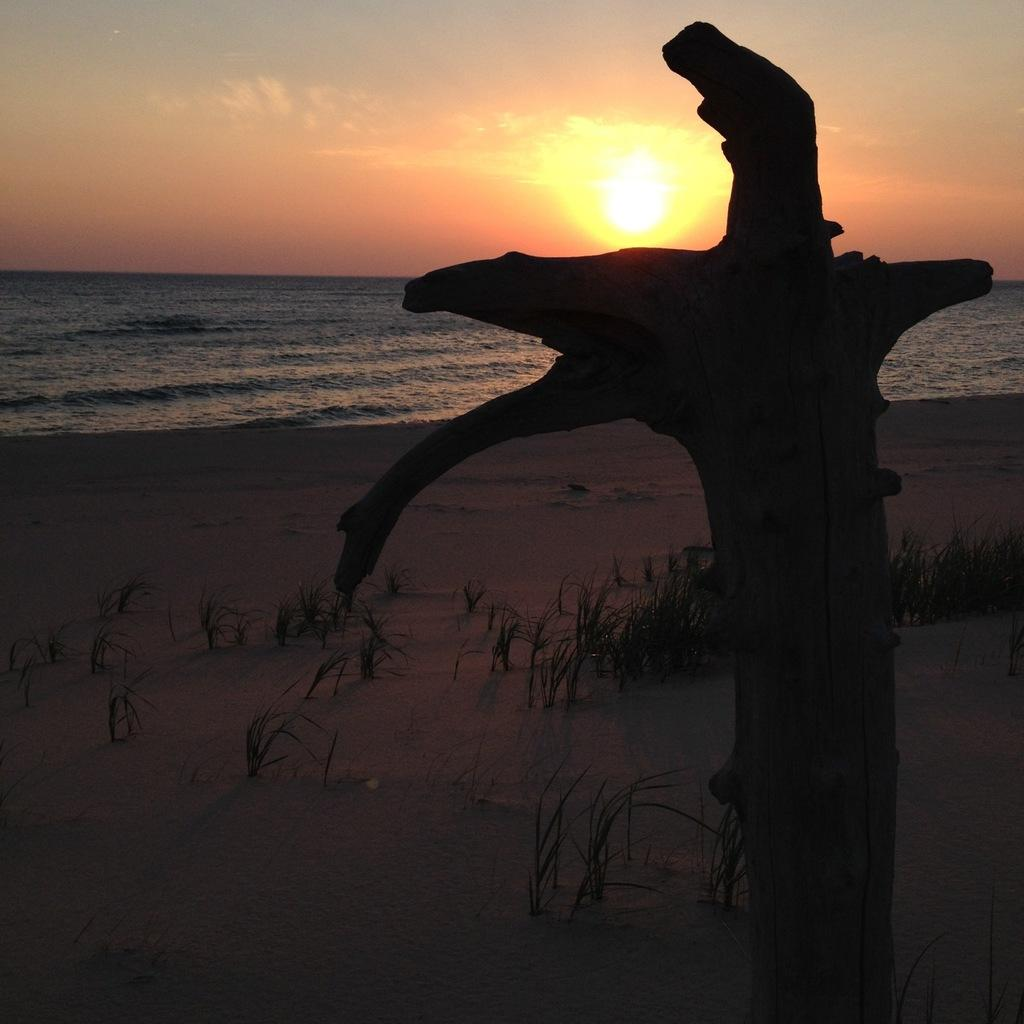What type of vegetation can be seen in the image? There is grass in the image. What natural element is also present in the image? There is water in the image. What can be seen in the sky in the image? There are clouds in the image. What is visible in the background of the image? The sky is visible in the image. What celestial body can be seen in the sky in the image? The sun is visible in the image. How would you describe the overall lighting in the image? The image appears to be slightly dark. What type of rail can be seen in the image? There is no rail present in the image. How many cacti are visible in the image? There are no cacti present in the image. 